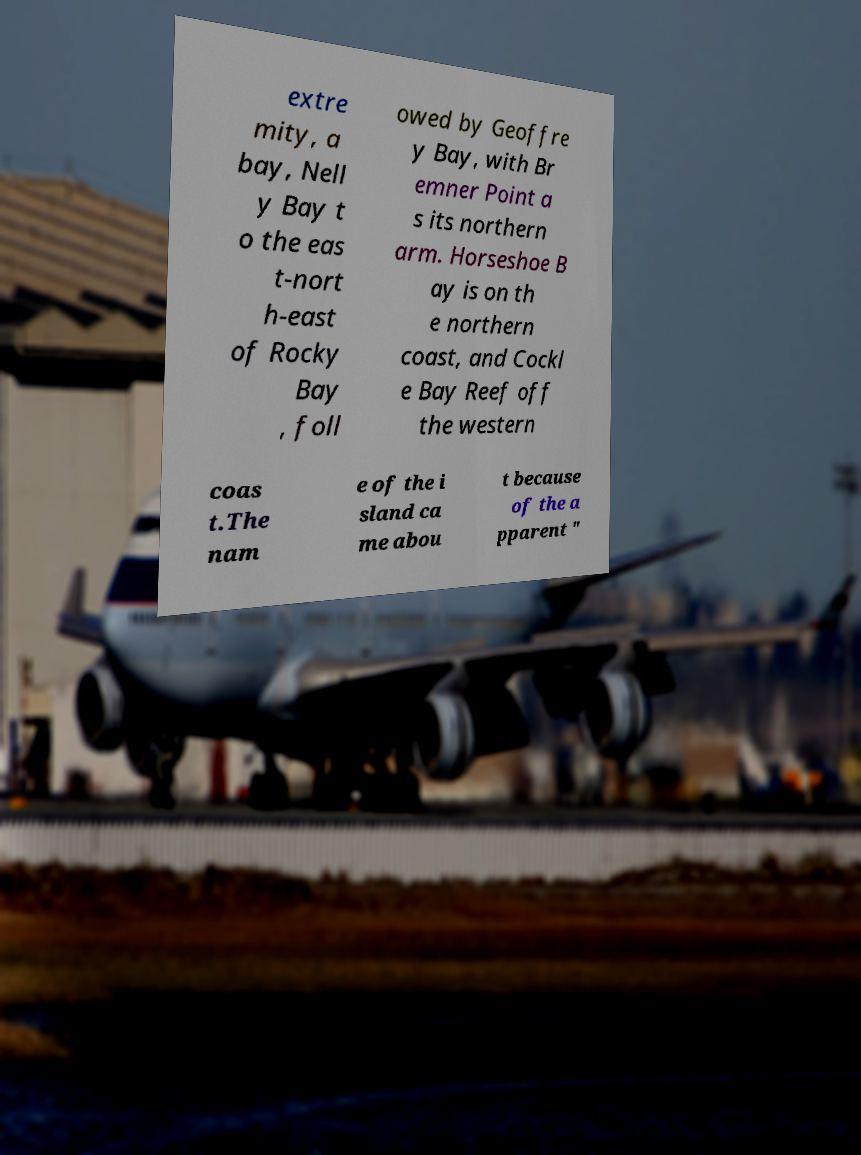Can you read and provide the text displayed in the image?This photo seems to have some interesting text. Can you extract and type it out for me? extre mity, a bay, Nell y Bay t o the eas t-nort h-east of Rocky Bay , foll owed by Geoffre y Bay, with Br emner Point a s its northern arm. Horseshoe B ay is on th e northern coast, and Cockl e Bay Reef off the western coas t.The nam e of the i sland ca me abou t because of the a pparent " 